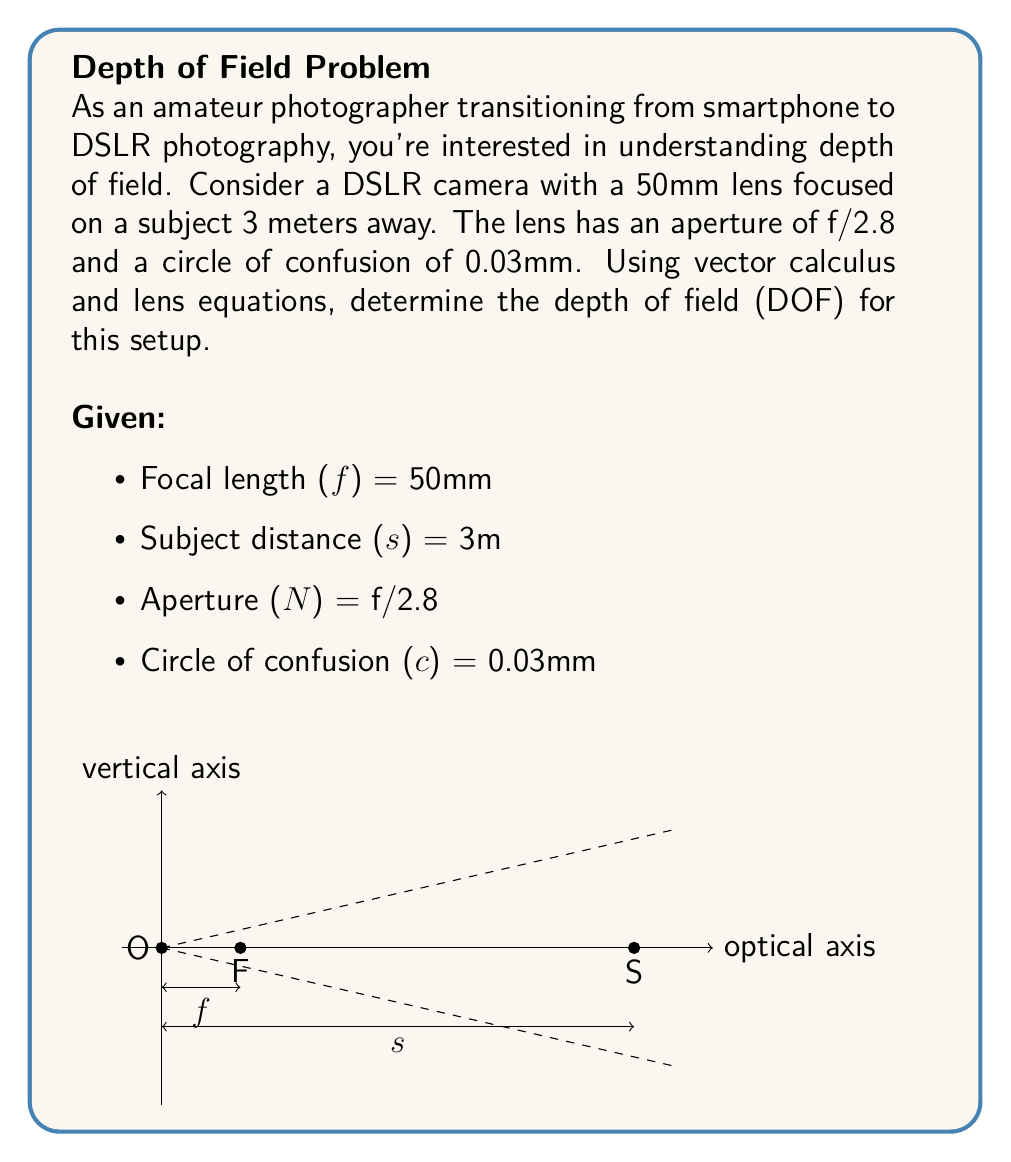Give your solution to this math problem. To solve this problem, we'll use the thin lens equation and the depth of field formula. Let's break it down step-by-step:

1) First, we need to convert all measurements to meters:
   f = 50mm = 0.05m
   s = 3m
   c = 0.03mm = 0.00003m

2) The thin lens equation is:
   $$\frac{1}{f} = \frac{1}{s} + \frac{1}{s'}$$
   where s' is the image distance.

3) Solving for s':
   $$\frac{1}{s'} = \frac{1}{f} - \frac{1}{s} = \frac{1}{0.05} - \frac{1}{3} = 20 - \frac{1}{3} = \frac{59}{3}$$
   $$s' = \frac{3}{59} \approx 0.0508m$$

4) The depth of field formula is:
   $$DOF = \frac{2Nc(s^2)}{f^2 + Nc(s - f)}$$
   where N is the f-number (aperture).

5) Calculating N:
   N = 2.8 (given as f/2.8)

6) Now, let's substitute all values into the DOF formula:
   $$DOF = \frac{2 \cdot 2.8 \cdot 0.00003 \cdot (3^2)}{0.05^2 + 2.8 \cdot 0.00003 \cdot (3 - 0.05)}$$

7) Simplifying:
   $$DOF = \frac{2 \cdot 2.8 \cdot 0.00003 \cdot 9}{0.0025 + 2.8 \cdot 0.00003 \cdot 2.95}$$
   $$DOF = \frac{0.0001512}{0.0025 + 0.0000248}$$
   $$DOF = \frac{0.0001512}{0.0025248} \approx 0.0599m$$

8) Converting back to millimeters:
   DOF ≈ 59.9mm

Therefore, the depth of field for this camera setup is approximately 59.9mm.
Answer: 59.9mm 